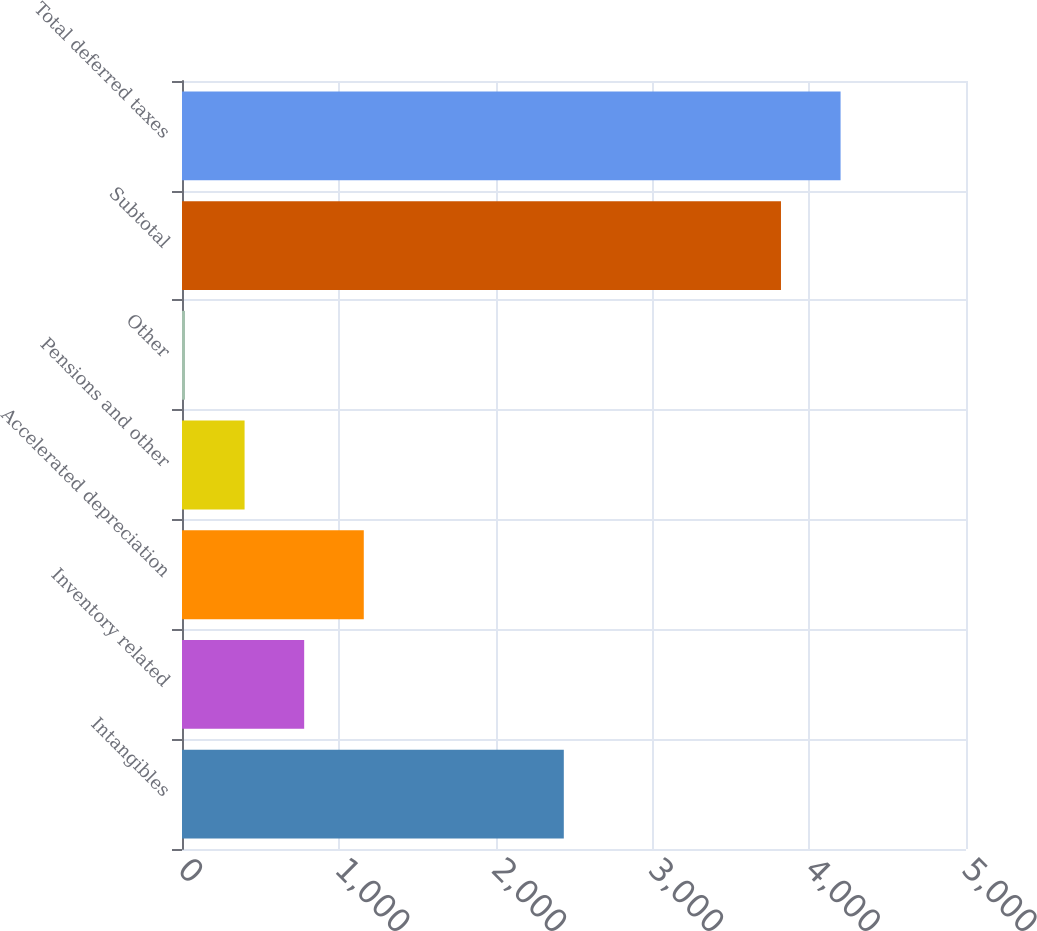Convert chart to OTSL. <chart><loc_0><loc_0><loc_500><loc_500><bar_chart><fcel>Intangibles<fcel>Inventory related<fcel>Accelerated depreciation<fcel>Pensions and other<fcel>Other<fcel>Subtotal<fcel>Total deferred taxes<nl><fcel>2435<fcel>779.2<fcel>1159.3<fcel>399.1<fcel>19<fcel>3820<fcel>4200.1<nl></chart> 